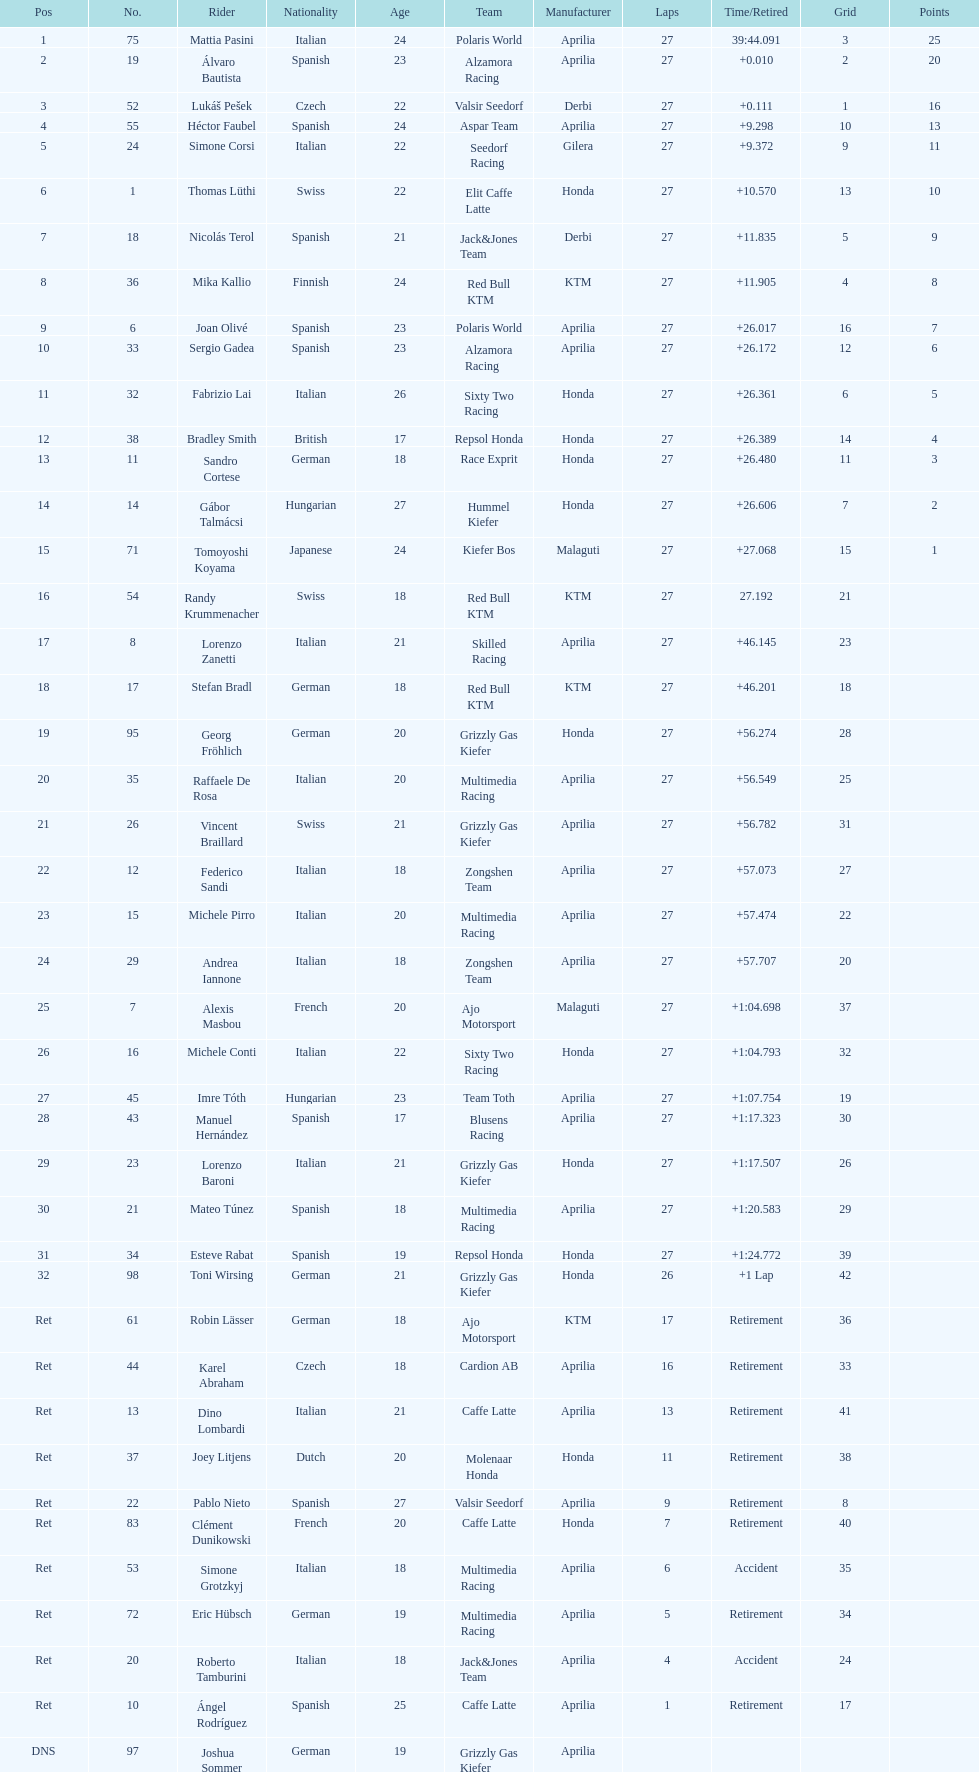Name a racer that had at least 20 points. Mattia Pasini. 